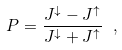<formula> <loc_0><loc_0><loc_500><loc_500>P = \frac { J ^ { \downarrow } - J ^ { \uparrow } } { J ^ { \downarrow } + J ^ { \uparrow } } \ ,</formula> 